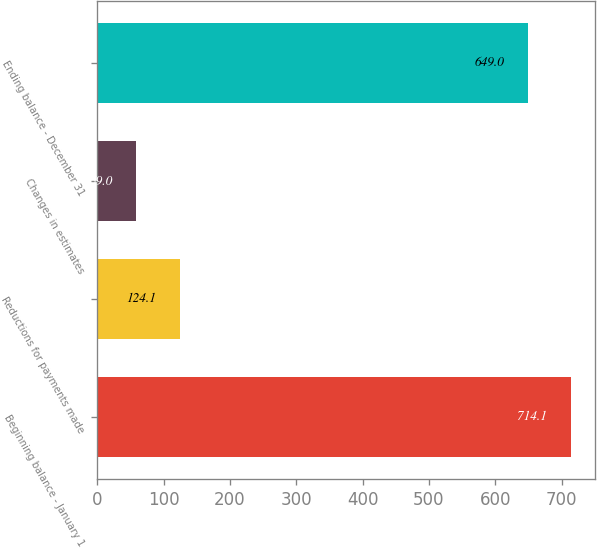Convert chart. <chart><loc_0><loc_0><loc_500><loc_500><bar_chart><fcel>Beginning balance - January 1<fcel>Reductions for payments made<fcel>Changes in estimates<fcel>Ending balance - December 31<nl><fcel>714.1<fcel>124.1<fcel>59<fcel>649<nl></chart> 